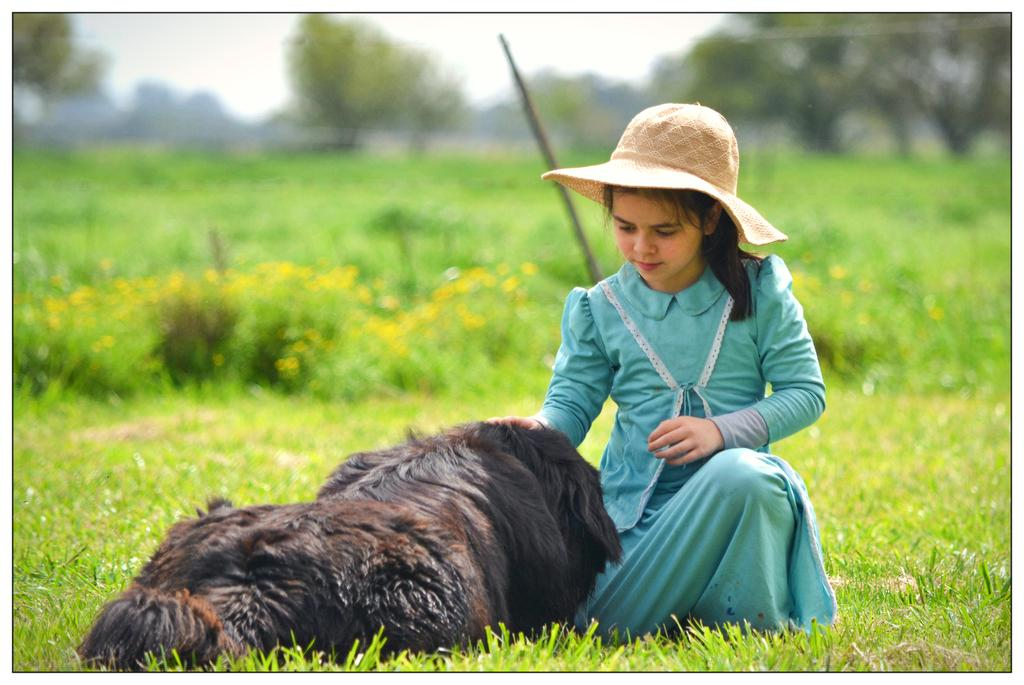What is the main subject of the image? There is a child in the image. Where is the child located? The child is sitting in the grass. What is the child wearing? The child is wearing a hat. What is in front of the child? There is a dog in front of the child. What can be seen in the background of the image? Plants and trees are visible in the background. What type of bubble can be seen floating near the child in the image? There is no bubble present in the image. What letter is the child holding in the image? There is no letter visible in the image. 